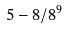Convert formula to latex. <formula><loc_0><loc_0><loc_500><loc_500>5 - 8 / 8 ^ { 9 }</formula> 